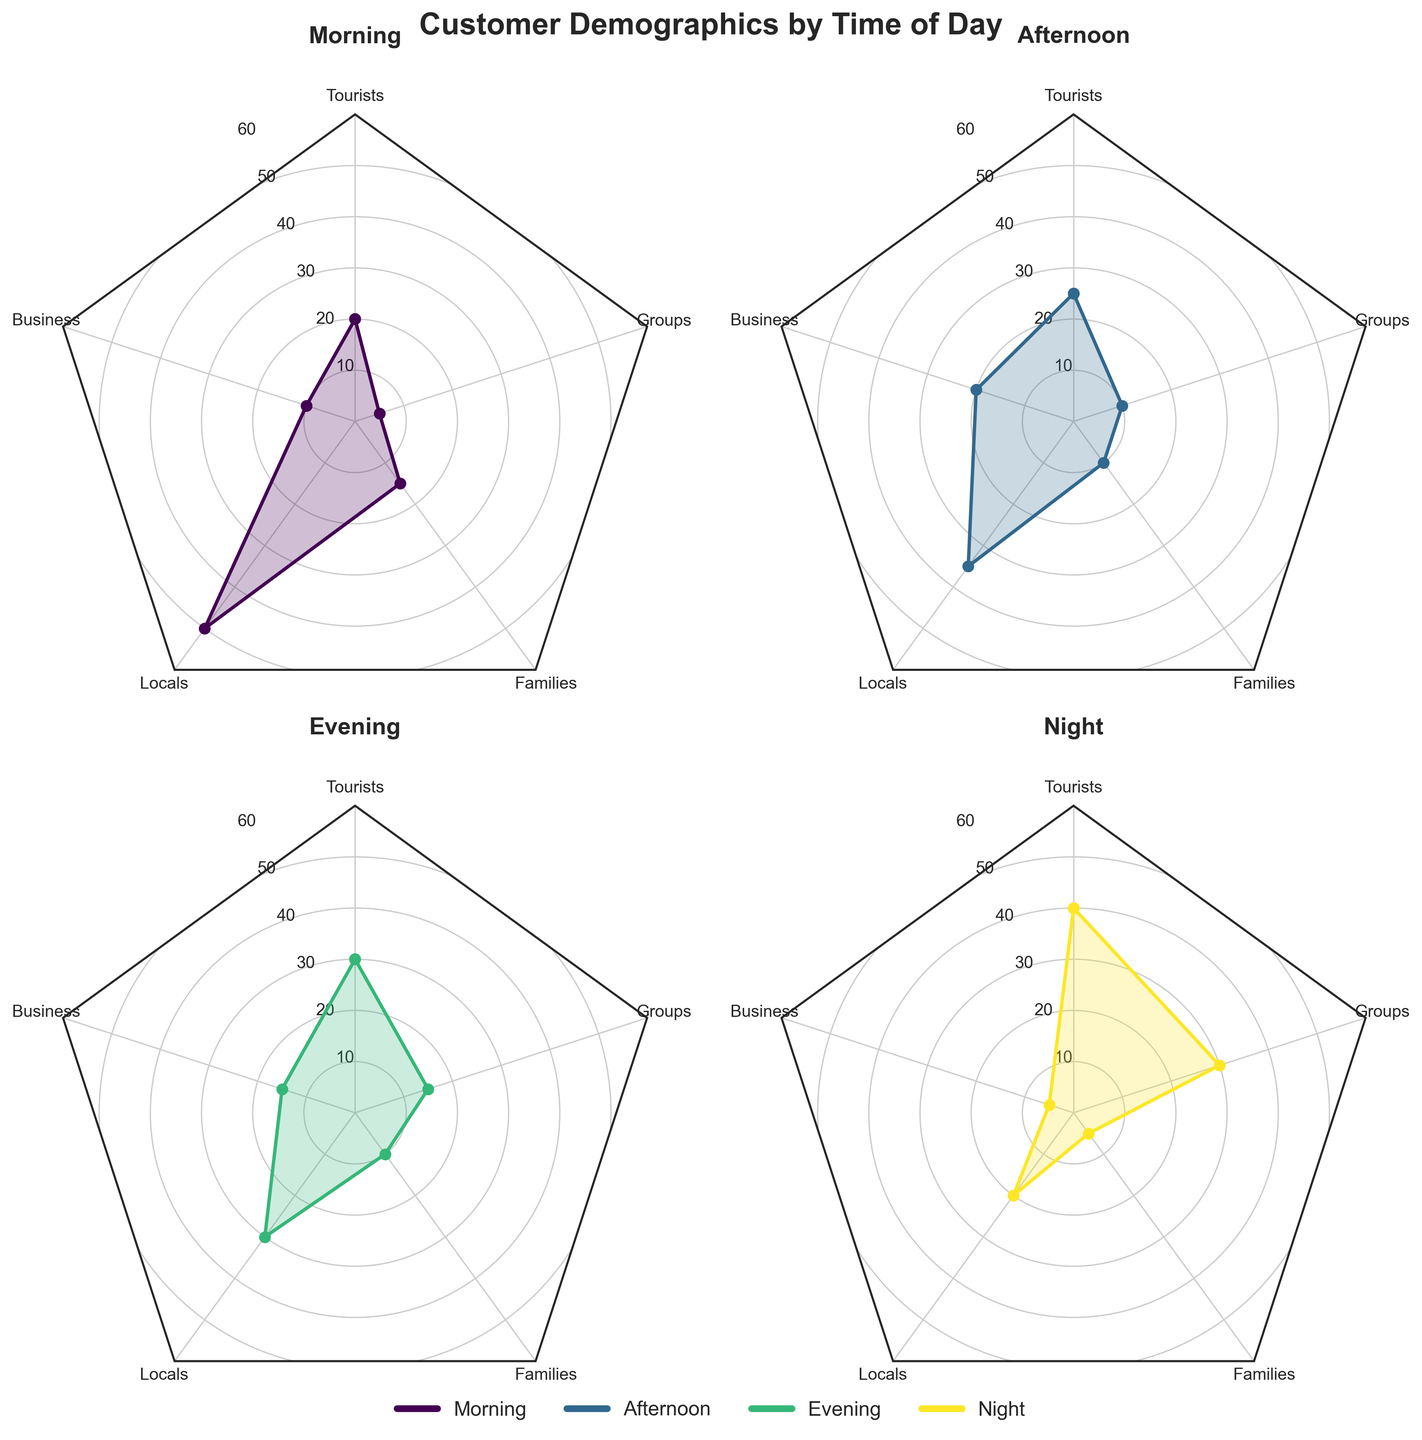Which demographic group has the highest percentage in the morning? In the morning, the highest percentage is for Locals at 50%. This is identified by looking at the "Morning" radar plot where the Locals segment reaches out to 50 on the chart.
Answer: Locals Which time of day has the lowest percentage for Business travelers? The lowest percentage for Business travelers is 5%, and it happens at night. This is indicated by the "Night" radar plot where the Business segment is closest to the center at 5.
Answer: Night By how much does the percentage of Tourists increase from the morning to the night? In the morning, the percentage of Tourists is 20%, and at night it is 40%. The increase is calculated as 40% - 20% = 20%.
Answer: 20% Which time of day has an equal percentage for Families and Groups? The evening has equal percentages for Families and Groups, both at 10%. This is seen in the "Evening" radar plot where both the Families and Groups segments extend to the same distance.
Answer: Evening What is the combined percentage of Locals and Business travelers in the afternoon? In the afternoon, the percentage for Locals is 35% and for Business travelers is 20%. The combined percentage is 35% + 20% = 55%.
Answer: 55% How does the percentage of Groups change from the evening to the night? In the evening, the percentage for Groups is 15%, and at night it is 30%. The change can be found by 30% - 15% = 15%.
Answer: 15% Which demographic group shows the most consistent percentage across all times of the day? Families have percentages of 15% in the morning, 10% in the afternoon, 10% in the evening, and 5% at night. The fluctuations are relatively small, making them the most consistent.
Answer: Families 